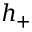<formula> <loc_0><loc_0><loc_500><loc_500>h _ { + }</formula> 